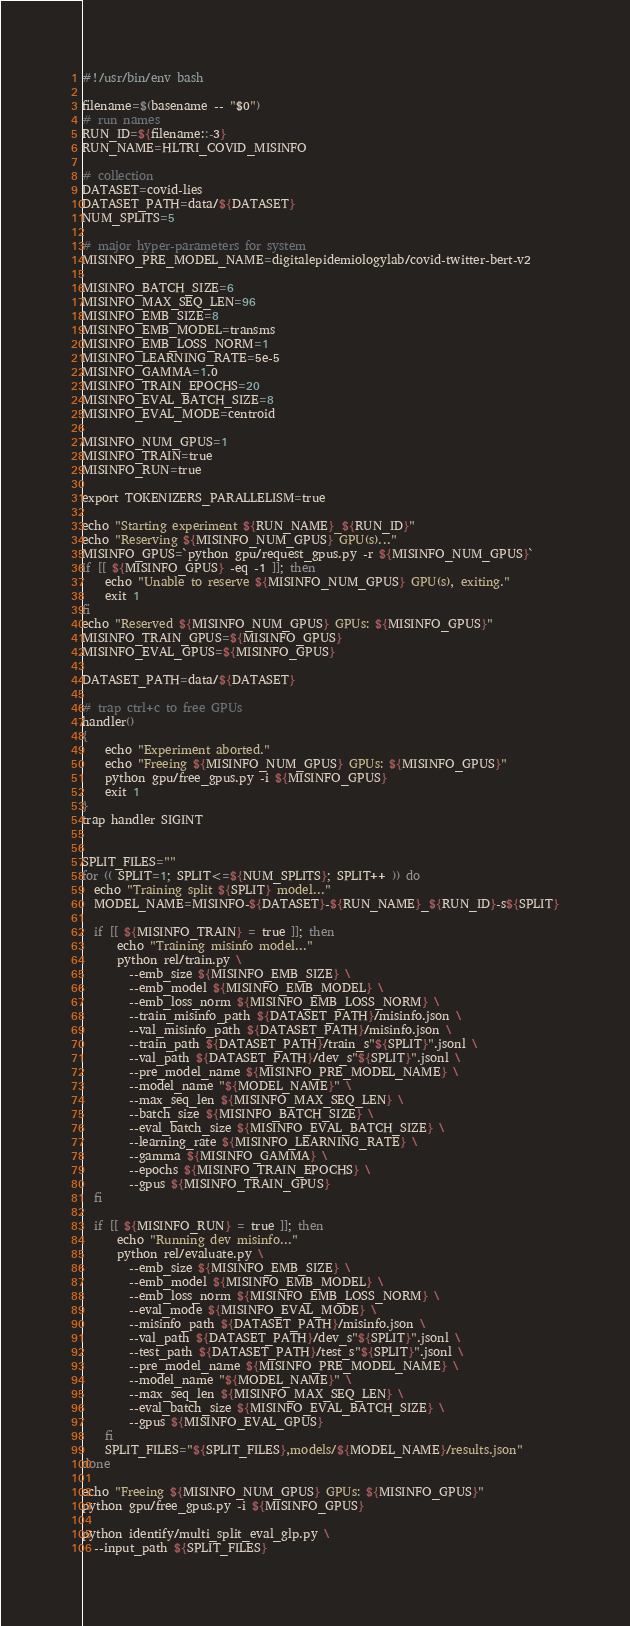<code> <loc_0><loc_0><loc_500><loc_500><_Bash_>#!/usr/bin/env bash

filename=$(basename -- "$0")
# run names
RUN_ID=${filename::-3}
RUN_NAME=HLTRI_COVID_MISINFO

# collection
DATASET=covid-lies
DATASET_PATH=data/${DATASET}
NUM_SPLITS=5

# major hyper-parameters for system
MISINFO_PRE_MODEL_NAME=digitalepidemiologylab/covid-twitter-bert-v2

MISINFO_BATCH_SIZE=6
MISINFO_MAX_SEQ_LEN=96
MISINFO_EMB_SIZE=8
MISINFO_EMB_MODEL=transms
MISINFO_EMB_LOSS_NORM=1
MISINFO_LEARNING_RATE=5e-5
MISINFO_GAMMA=1.0
MISINFO_TRAIN_EPOCHS=20
MISINFO_EVAL_BATCH_SIZE=8
MISINFO_EVAL_MODE=centroid

MISINFO_NUM_GPUS=1
MISINFO_TRAIN=true
MISINFO_RUN=true

export TOKENIZERS_PARALLELISM=true

echo "Starting experiment ${RUN_NAME}_${RUN_ID}"
echo "Reserving ${MISINFO_NUM_GPUS} GPU(s)..."
MISINFO_GPUS=`python gpu/request_gpus.py -r ${MISINFO_NUM_GPUS}`
if [[ ${MISINFO_GPUS} -eq -1 ]]; then
    echo "Unable to reserve ${MISINFO_NUM_GPUS} GPU(s), exiting."
    exit 1
fi
echo "Reserved ${MISINFO_NUM_GPUS} GPUs: ${MISINFO_GPUS}"
MISINFO_TRAIN_GPUS=${MISINFO_GPUS}
MISINFO_EVAL_GPUS=${MISINFO_GPUS}

DATASET_PATH=data/${DATASET}

# trap ctrl+c to free GPUs
handler()
{
    echo "Experiment aborted."
    echo "Freeing ${MISINFO_NUM_GPUS} GPUs: ${MISINFO_GPUS}"
    python gpu/free_gpus.py -i ${MISINFO_GPUS}
    exit 1
}
trap handler SIGINT


SPLIT_FILES=""
for (( SPLIT=1; SPLIT<=${NUM_SPLITS}; SPLIT++ )) do
  echo "Training split ${SPLIT} model..."
  MODEL_NAME=MISINFO-${DATASET}-${RUN_NAME}_${RUN_ID}-s${SPLIT}

  if [[ ${MISINFO_TRAIN} = true ]]; then
      echo "Training misinfo model..."
      python rel/train.py \
        --emb_size ${MISINFO_EMB_SIZE} \
        --emb_model ${MISINFO_EMB_MODEL} \
        --emb_loss_norm ${MISINFO_EMB_LOSS_NORM} \
        --train_misinfo_path ${DATASET_PATH}/misinfo.json \
        --val_misinfo_path ${DATASET_PATH}/misinfo.json \
        --train_path ${DATASET_PATH}/train_s"${SPLIT}".jsonl \
        --val_path ${DATASET_PATH}/dev_s"${SPLIT}".jsonl \
        --pre_model_name ${MISINFO_PRE_MODEL_NAME} \
        --model_name "${MODEL_NAME}" \
        --max_seq_len ${MISINFO_MAX_SEQ_LEN} \
        --batch_size ${MISINFO_BATCH_SIZE} \
        --eval_batch_size ${MISINFO_EVAL_BATCH_SIZE} \
        --learning_rate ${MISINFO_LEARNING_RATE} \
        --gamma ${MISINFO_GAMMA} \
        --epochs ${MISINFO_TRAIN_EPOCHS} \
        --gpus ${MISINFO_TRAIN_GPUS}
  fi

  if [[ ${MISINFO_RUN} = true ]]; then
      echo "Running dev misinfo..."
      python rel/evaluate.py \
        --emb_size ${MISINFO_EMB_SIZE} \
        --emb_model ${MISINFO_EMB_MODEL} \
        --emb_loss_norm ${MISINFO_EMB_LOSS_NORM} \
        --eval_mode ${MISINFO_EVAL_MODE} \
        --misinfo_path ${DATASET_PATH}/misinfo.json \
        --val_path ${DATASET_PATH}/dev_s"${SPLIT}".jsonl \
        --test_path ${DATASET_PATH}/test_s"${SPLIT}".jsonl \
        --pre_model_name ${MISINFO_PRE_MODEL_NAME} \
        --model_name "${MODEL_NAME}" \
        --max_seq_len ${MISINFO_MAX_SEQ_LEN} \
        --eval_batch_size ${MISINFO_EVAL_BATCH_SIZE} \
        --gpus ${MISINFO_EVAL_GPUS}
    fi
    SPLIT_FILES="${SPLIT_FILES},models/${MODEL_NAME}/results.json"
done

echo "Freeing ${MISINFO_NUM_GPUS} GPUs: ${MISINFO_GPUS}"
python gpu/free_gpus.py -i ${MISINFO_GPUS}

python identify/multi_split_eval_glp.py \
  --input_path ${SPLIT_FILES}
</code> 